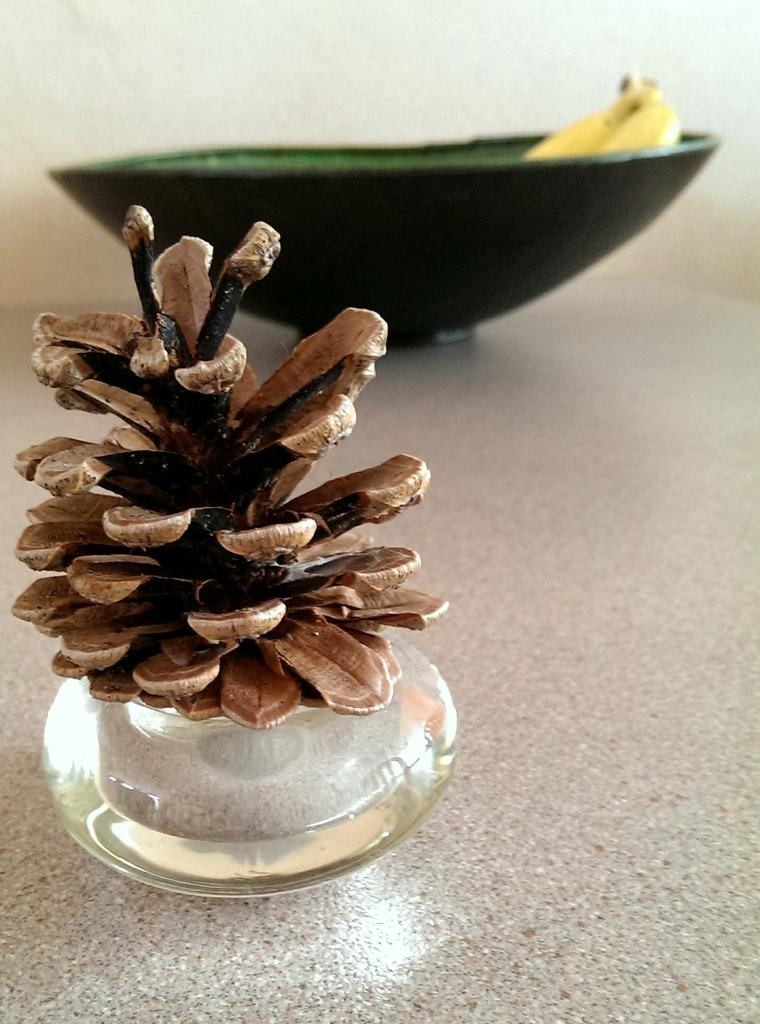What type of object is made of wood in the image? There is a wooden object in the image, but its specific nature cannot be determined from the provided facts. What can be seen in the background of the image? There is a bowl in the background of the image. Can you hear a duck crying in the image? There is no mention of a duck or any sound in the image, so it cannot be determined if a duck is crying. 